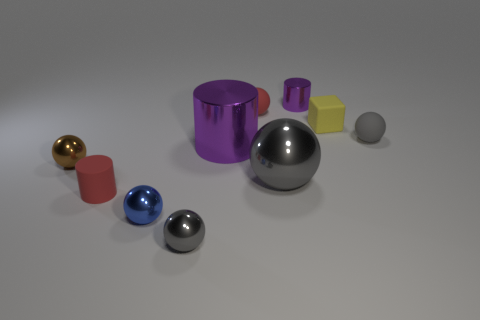How does the size of the largest sphere compare to the other objects? The largest sphere is medium-sized when compared to the other objects. It is significantly larger than the small spheres, but slightly smaller than the large purple cylinder and comparable in size to the gold-colored cylinder. 